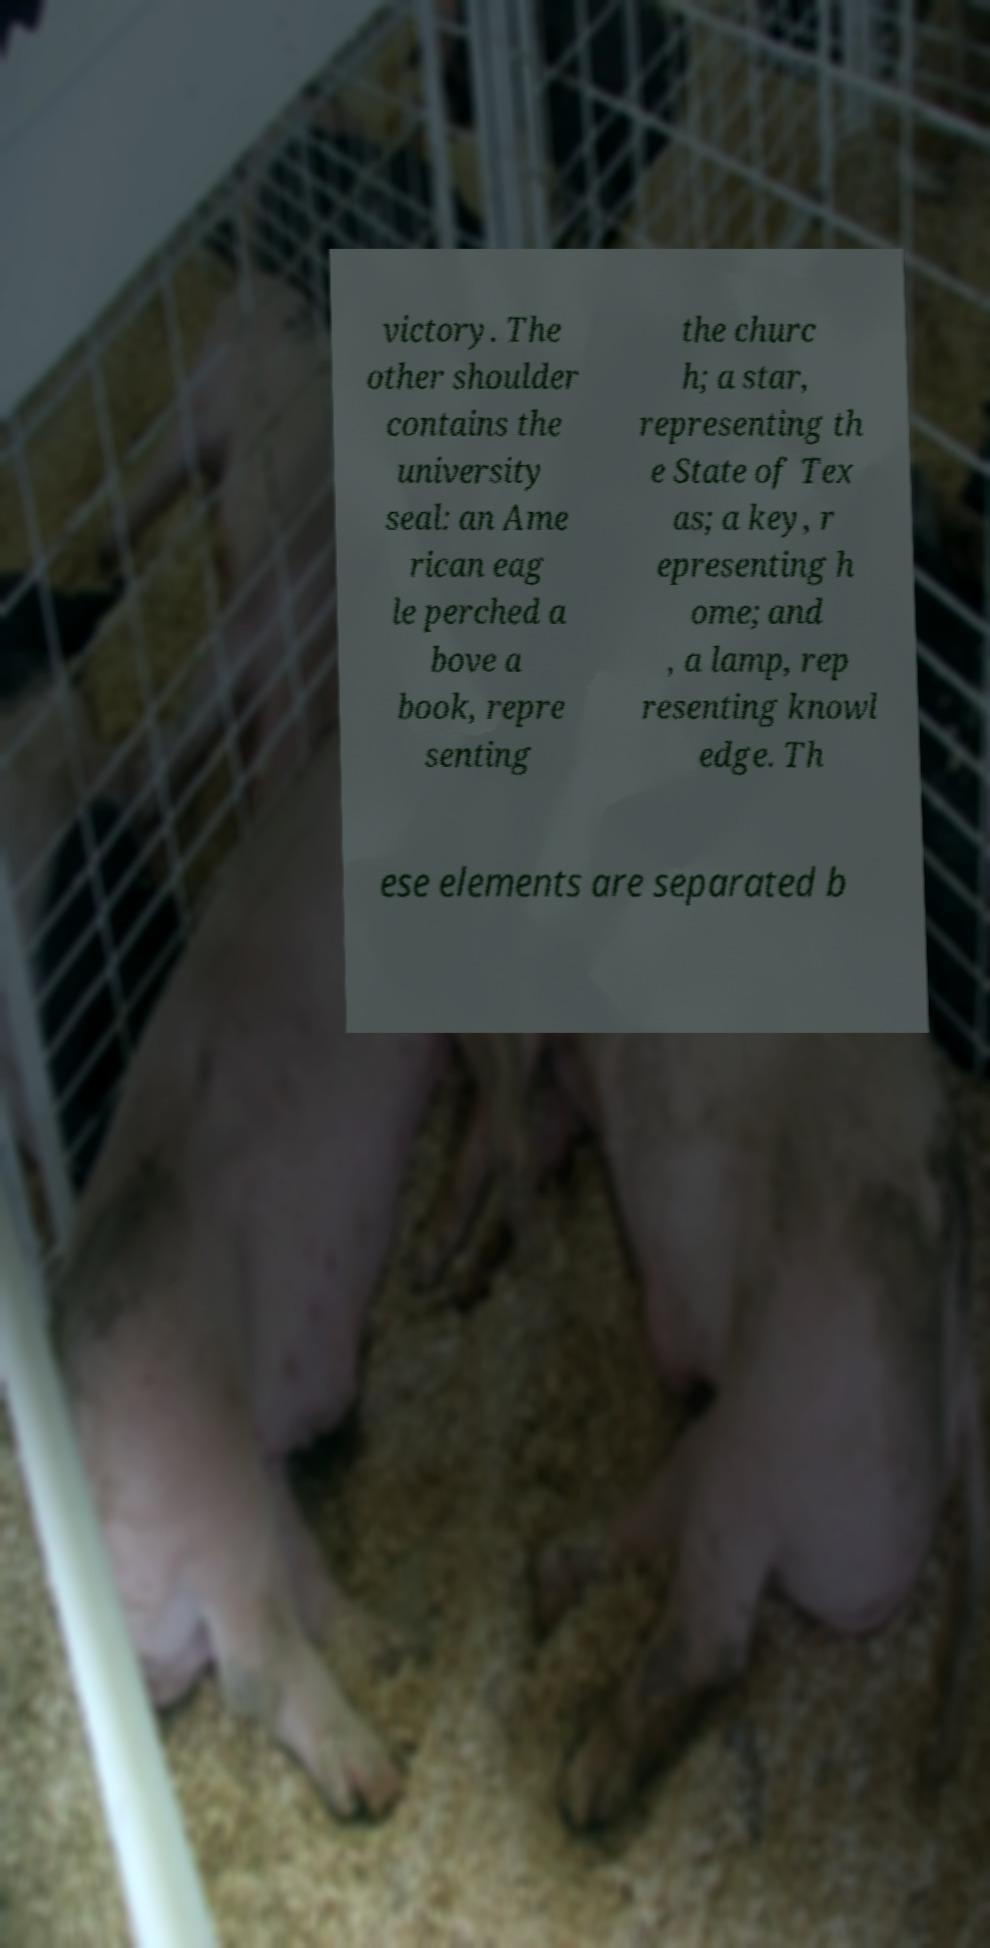There's text embedded in this image that I need extracted. Can you transcribe it verbatim? victory. The other shoulder contains the university seal: an Ame rican eag le perched a bove a book, repre senting the churc h; a star, representing th e State of Tex as; a key, r epresenting h ome; and , a lamp, rep resenting knowl edge. Th ese elements are separated b 